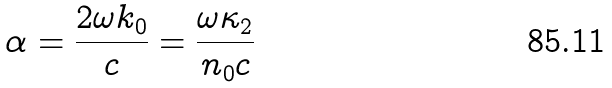<formula> <loc_0><loc_0><loc_500><loc_500>\alpha = \frac { 2 \omega k _ { 0 } } { c } = \frac { \omega \kappa _ { 2 } } { n _ { 0 } c }</formula> 